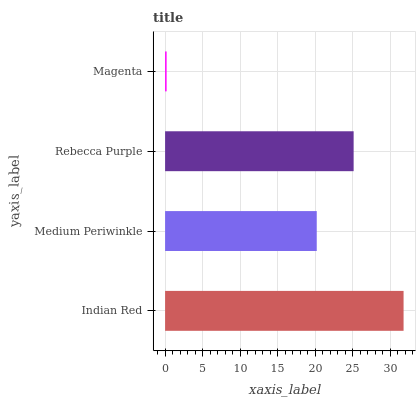Is Magenta the minimum?
Answer yes or no. Yes. Is Indian Red the maximum?
Answer yes or no. Yes. Is Medium Periwinkle the minimum?
Answer yes or no. No. Is Medium Periwinkle the maximum?
Answer yes or no. No. Is Indian Red greater than Medium Periwinkle?
Answer yes or no. Yes. Is Medium Periwinkle less than Indian Red?
Answer yes or no. Yes. Is Medium Periwinkle greater than Indian Red?
Answer yes or no. No. Is Indian Red less than Medium Periwinkle?
Answer yes or no. No. Is Rebecca Purple the high median?
Answer yes or no. Yes. Is Medium Periwinkle the low median?
Answer yes or no. Yes. Is Magenta the high median?
Answer yes or no. No. Is Magenta the low median?
Answer yes or no. No. 